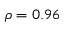Convert formula to latex. <formula><loc_0><loc_0><loc_500><loc_500>\rho = 0 . 9 6</formula> 